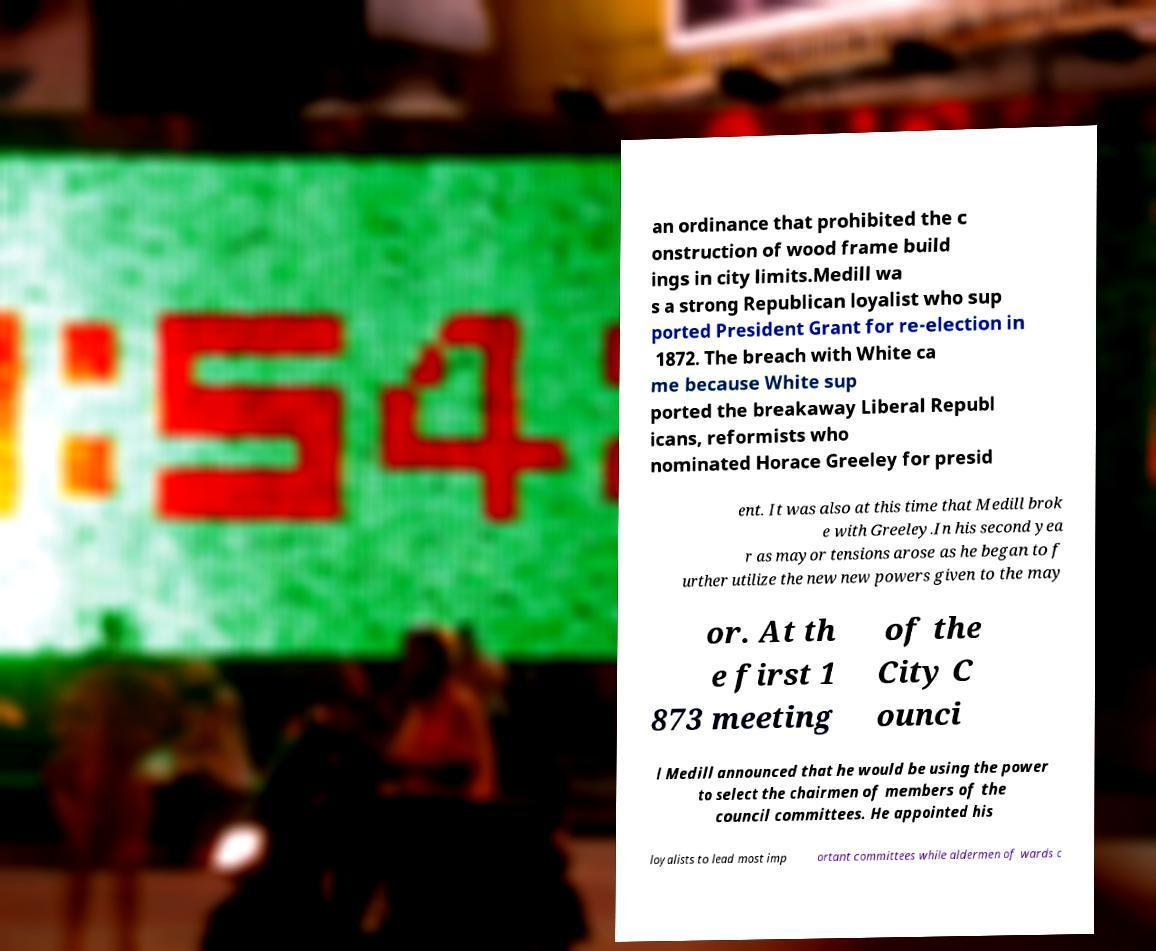I need the written content from this picture converted into text. Can you do that? an ordinance that prohibited the c onstruction of wood frame build ings in city limits.Medill wa s a strong Republican loyalist who sup ported President Grant for re-election in 1872. The breach with White ca me because White sup ported the breakaway Liberal Republ icans, reformists who nominated Horace Greeley for presid ent. It was also at this time that Medill brok e with Greeley.In his second yea r as mayor tensions arose as he began to f urther utilize the new new powers given to the may or. At th e first 1 873 meeting of the City C ounci l Medill announced that he would be using the power to select the chairmen of members of the council committees. He appointed his loyalists to lead most imp ortant committees while aldermen of wards c 